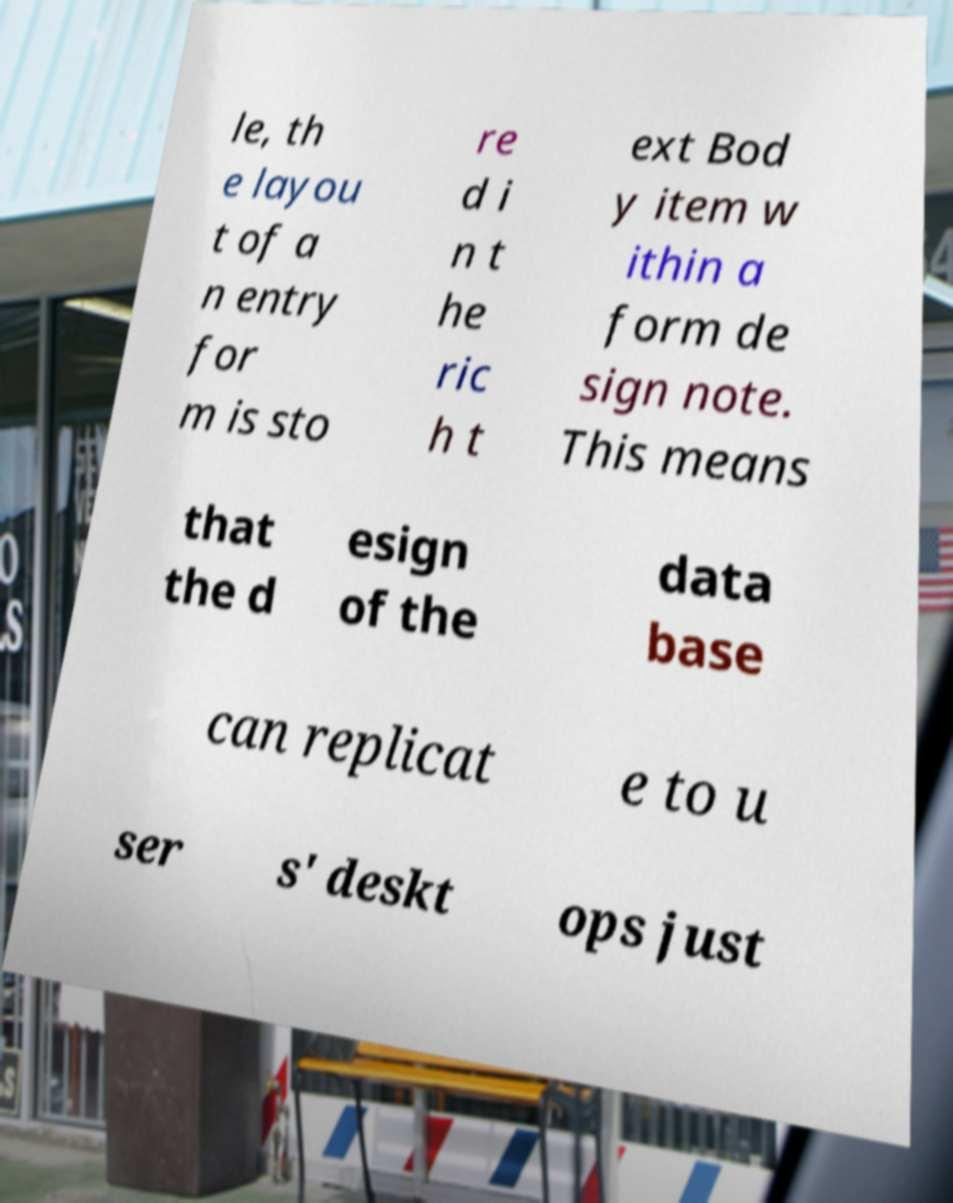Can you accurately transcribe the text from the provided image for me? le, th e layou t of a n entry for m is sto re d i n t he ric h t ext Bod y item w ithin a form de sign note. This means that the d esign of the data base can replicat e to u ser s' deskt ops just 